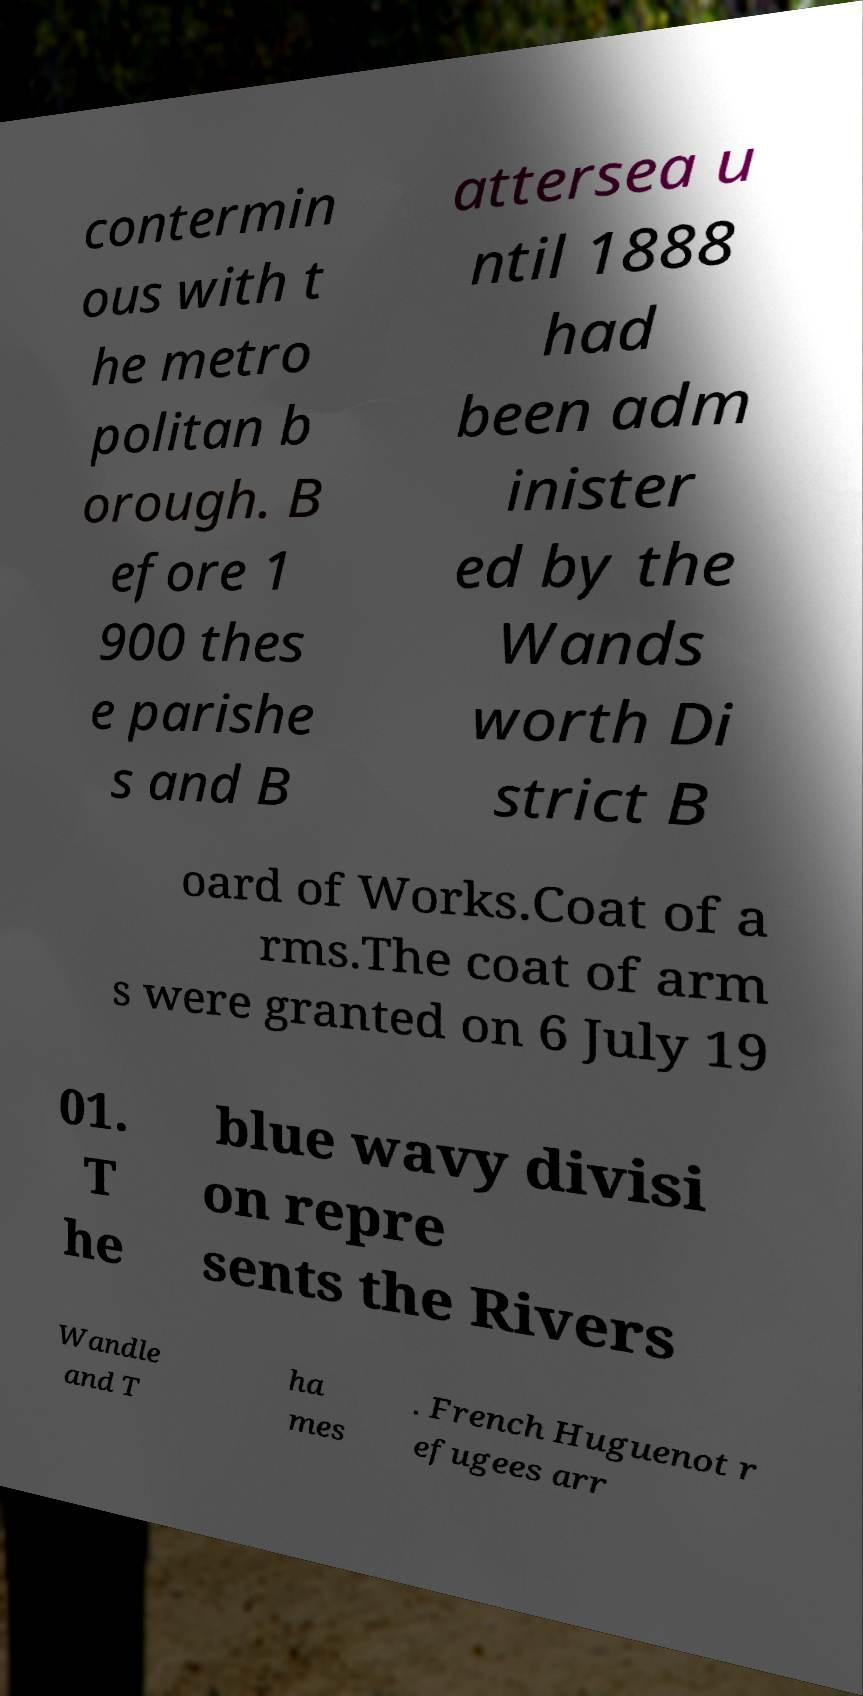Can you read and provide the text displayed in the image?This photo seems to have some interesting text. Can you extract and type it out for me? contermin ous with t he metro politan b orough. B efore 1 900 thes e parishe s and B attersea u ntil 1888 had been adm inister ed by the Wands worth Di strict B oard of Works.Coat of a rms.The coat of arm s were granted on 6 July 19 01. T he blue wavy divisi on repre sents the Rivers Wandle and T ha mes . French Huguenot r efugees arr 